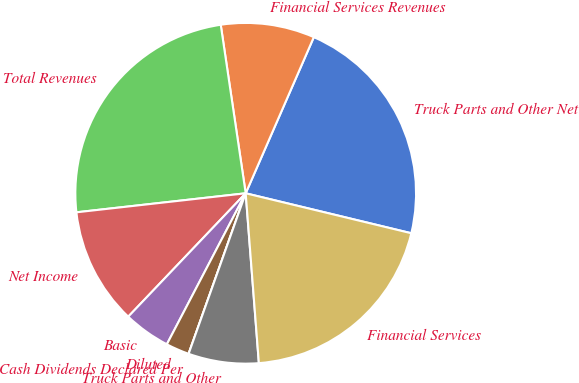Convert chart to OTSL. <chart><loc_0><loc_0><loc_500><loc_500><pie_chart><fcel>Truck Parts and Other Net<fcel>Financial Services Revenues<fcel>Total Revenues<fcel>Net Income<fcel>Basic<fcel>Diluted<fcel>Cash Dividends Declared Per<fcel>Truck Parts and Other<fcel>Financial Services<nl><fcel>22.22%<fcel>8.89%<fcel>24.44%<fcel>11.11%<fcel>4.45%<fcel>2.22%<fcel>0.0%<fcel>6.67%<fcel>20.0%<nl></chart> 